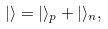<formula> <loc_0><loc_0><loc_500><loc_500>| \rangle = | \rangle _ { p } + | \rangle _ { n } ,</formula> 